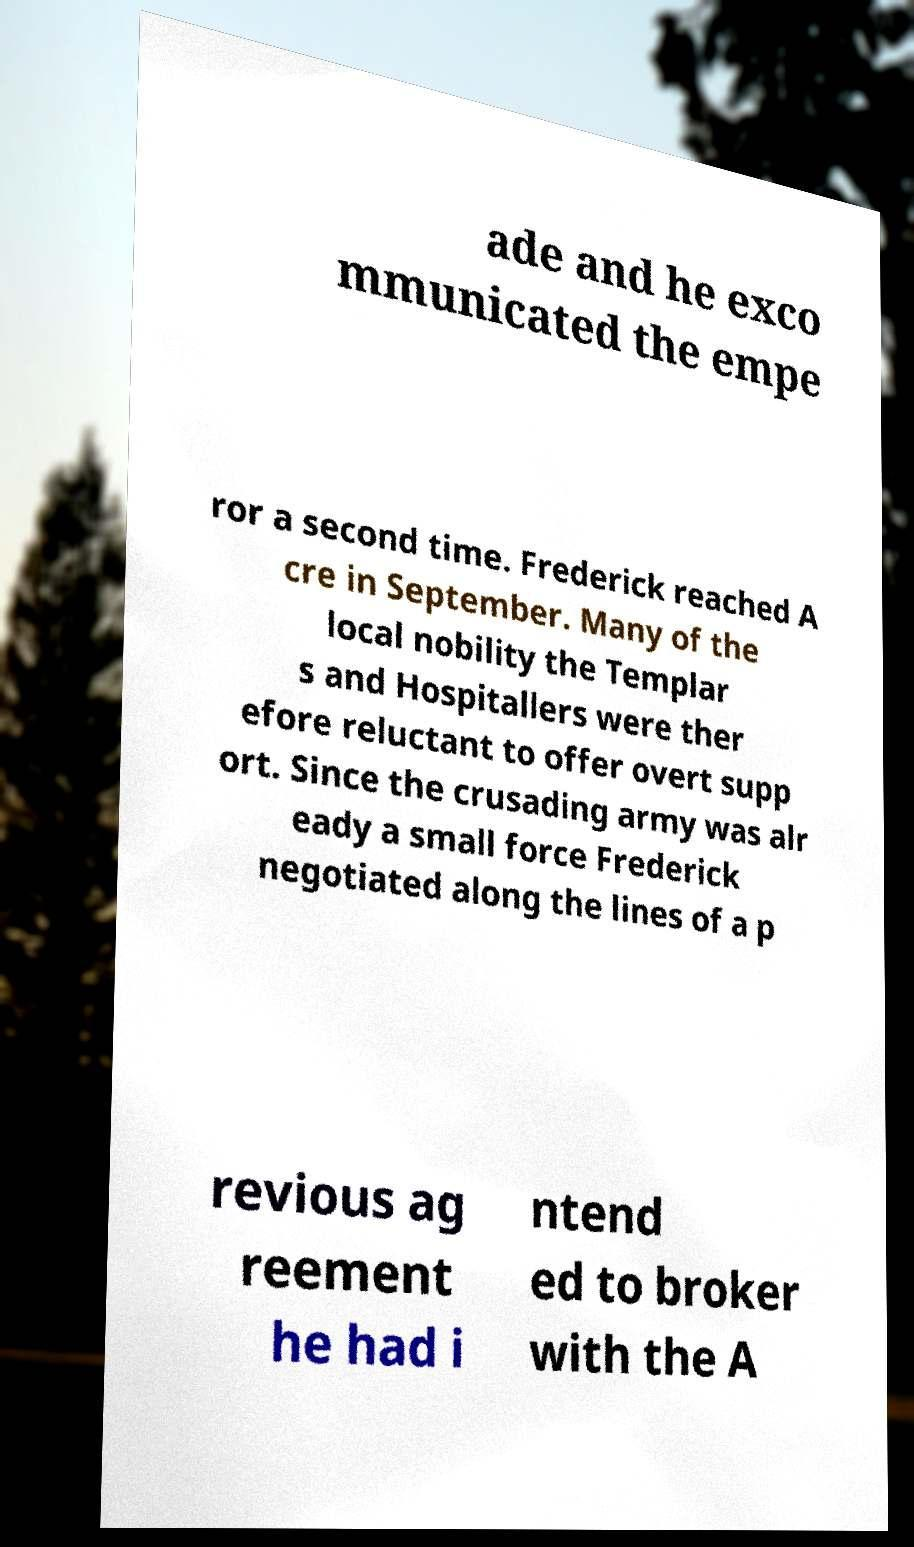I need the written content from this picture converted into text. Can you do that? ade and he exco mmunicated the empe ror a second time. Frederick reached A cre in September. Many of the local nobility the Templar s and Hospitallers were ther efore reluctant to offer overt supp ort. Since the crusading army was alr eady a small force Frederick negotiated along the lines of a p revious ag reement he had i ntend ed to broker with the A 